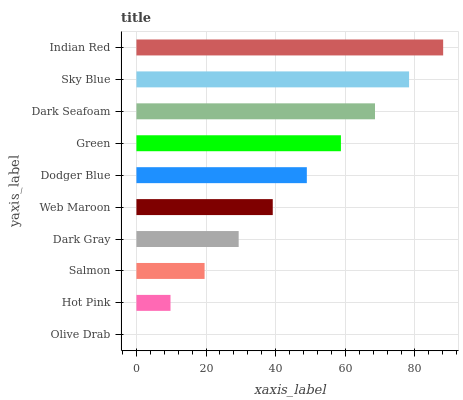Is Olive Drab the minimum?
Answer yes or no. Yes. Is Indian Red the maximum?
Answer yes or no. Yes. Is Hot Pink the minimum?
Answer yes or no. No. Is Hot Pink the maximum?
Answer yes or no. No. Is Hot Pink greater than Olive Drab?
Answer yes or no. Yes. Is Olive Drab less than Hot Pink?
Answer yes or no. Yes. Is Olive Drab greater than Hot Pink?
Answer yes or no. No. Is Hot Pink less than Olive Drab?
Answer yes or no. No. Is Dodger Blue the high median?
Answer yes or no. Yes. Is Web Maroon the low median?
Answer yes or no. Yes. Is Web Maroon the high median?
Answer yes or no. No. Is Dodger Blue the low median?
Answer yes or no. No. 